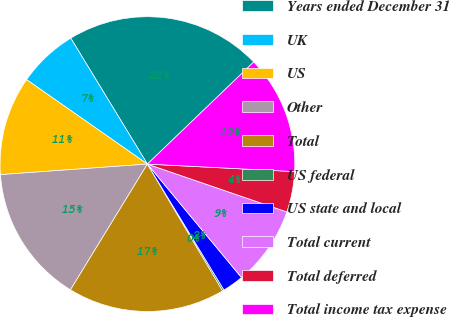Convert chart to OTSL. <chart><loc_0><loc_0><loc_500><loc_500><pie_chart><fcel>Years ended December 31<fcel>UK<fcel>US<fcel>Other<fcel>Total<fcel>US federal<fcel>US state and local<fcel>Total current<fcel>Total deferred<fcel>Total income tax expense<nl><fcel>21.53%<fcel>6.59%<fcel>10.85%<fcel>15.12%<fcel>17.26%<fcel>0.18%<fcel>2.32%<fcel>8.72%<fcel>4.45%<fcel>12.99%<nl></chart> 